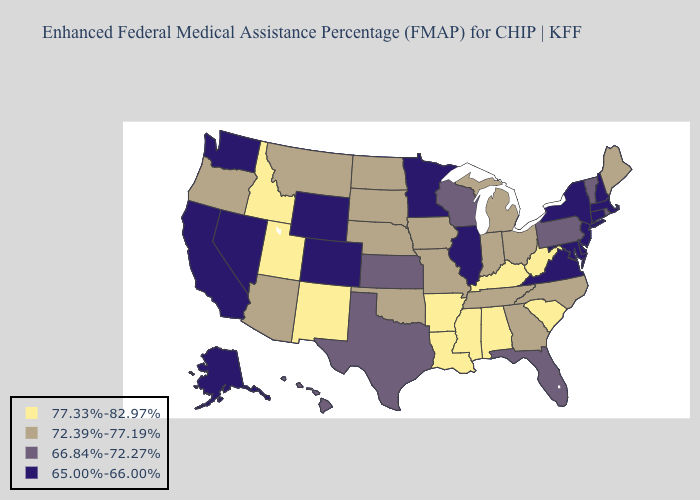Name the states that have a value in the range 77.33%-82.97%?
Quick response, please. Alabama, Arkansas, Idaho, Kentucky, Louisiana, Mississippi, New Mexico, South Carolina, Utah, West Virginia. What is the value of South Carolina?
Be succinct. 77.33%-82.97%. Does Florida have a lower value than Connecticut?
Give a very brief answer. No. What is the value of Nebraska?
Concise answer only. 72.39%-77.19%. Does Vermont have the same value as Arizona?
Concise answer only. No. Name the states that have a value in the range 65.00%-66.00%?
Be succinct. Alaska, California, Colorado, Connecticut, Delaware, Illinois, Maryland, Massachusetts, Minnesota, Nevada, New Hampshire, New Jersey, New York, Virginia, Washington, Wyoming. Name the states that have a value in the range 72.39%-77.19%?
Give a very brief answer. Arizona, Georgia, Indiana, Iowa, Maine, Michigan, Missouri, Montana, Nebraska, North Carolina, North Dakota, Ohio, Oklahoma, Oregon, South Dakota, Tennessee. What is the value of Pennsylvania?
Keep it brief. 66.84%-72.27%. Does Illinois have the lowest value in the MidWest?
Answer briefly. Yes. Among the states that border Ohio , does Pennsylvania have the lowest value?
Short answer required. Yes. What is the value of South Carolina?
Quick response, please. 77.33%-82.97%. Name the states that have a value in the range 66.84%-72.27%?
Quick response, please. Florida, Hawaii, Kansas, Pennsylvania, Rhode Island, Texas, Vermont, Wisconsin. Among the states that border Washington , which have the highest value?
Concise answer only. Idaho. Does Indiana have a higher value than West Virginia?
Answer briefly. No. Name the states that have a value in the range 65.00%-66.00%?
Give a very brief answer. Alaska, California, Colorado, Connecticut, Delaware, Illinois, Maryland, Massachusetts, Minnesota, Nevada, New Hampshire, New Jersey, New York, Virginia, Washington, Wyoming. 